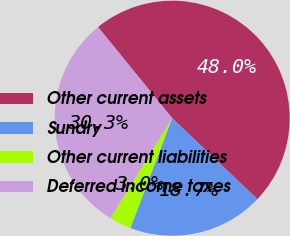<chart> <loc_0><loc_0><loc_500><loc_500><pie_chart><fcel>Other current assets<fcel>Sundry<fcel>Other current liabilities<fcel>Deferred income taxes<nl><fcel>47.97%<fcel>18.69%<fcel>3.0%<fcel>30.34%<nl></chart> 